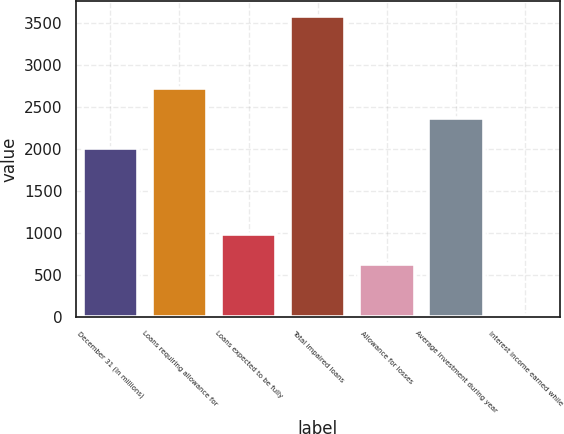<chart> <loc_0><loc_0><loc_500><loc_500><bar_chart><fcel>December 31 (In millions)<fcel>Loans requiring allowance for<fcel>Loans expected to be fully<fcel>Total impaired loans<fcel>Allowance for losses<fcel>Average investment during year<fcel>Interest income earned while<nl><fcel>2008<fcel>2719.2<fcel>990.6<fcel>3583<fcel>635<fcel>2363.6<fcel>27<nl></chart> 